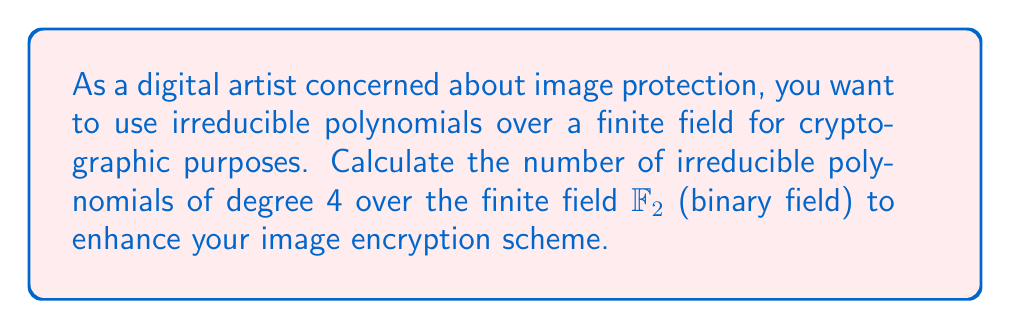Give your solution to this math problem. To find the number of irreducible polynomials of degree 4 over $\mathbb{F}_2$, we can use the following steps:

1) First, recall the formula for the number of monic irreducible polynomials of degree $n$ over $\mathbb{F}_q$:

   $$N_q(n) = \frac{1}{n} \sum_{d|n} \mu(d)q^{n/d}$$

   where $\mu(d)$ is the Möbius function.

2) In our case, $q = 2$ (binary field) and $n = 4$. Let's substitute these values:

   $$N_2(4) = \frac{1}{4} \sum_{d|4} \mu(d)2^{4/d}$$

3) The divisors of 4 are 1, 2, and 4. Let's calculate $\mu(d)$ for each:
   - $\mu(1) = 1$
   - $\mu(2) = -1$
   - $\mu(4) = 0$

4) Now, let's calculate each term in the sum:
   - For $d = 1$: $\mu(1)2^{4/1} = 1 \cdot 2^4 = 16$
   - For $d = 2$: $\mu(2)2^{4/2} = -1 \cdot 2^2 = -4$
   - For $d = 4$: $\mu(4)2^{4/4} = 0 \cdot 2^1 = 0$

5) Sum these terms:
   $$\sum_{d|4} \mu(d)2^{4/d} = 16 - 4 + 0 = 12$$

6) Finally, divide by 4:
   $$N_2(4) = \frac{1}{4} \cdot 12 = 3$$

Therefore, there are 3 irreducible polynomials of degree 4 over $\mathbb{F}_2$.
Answer: 3 